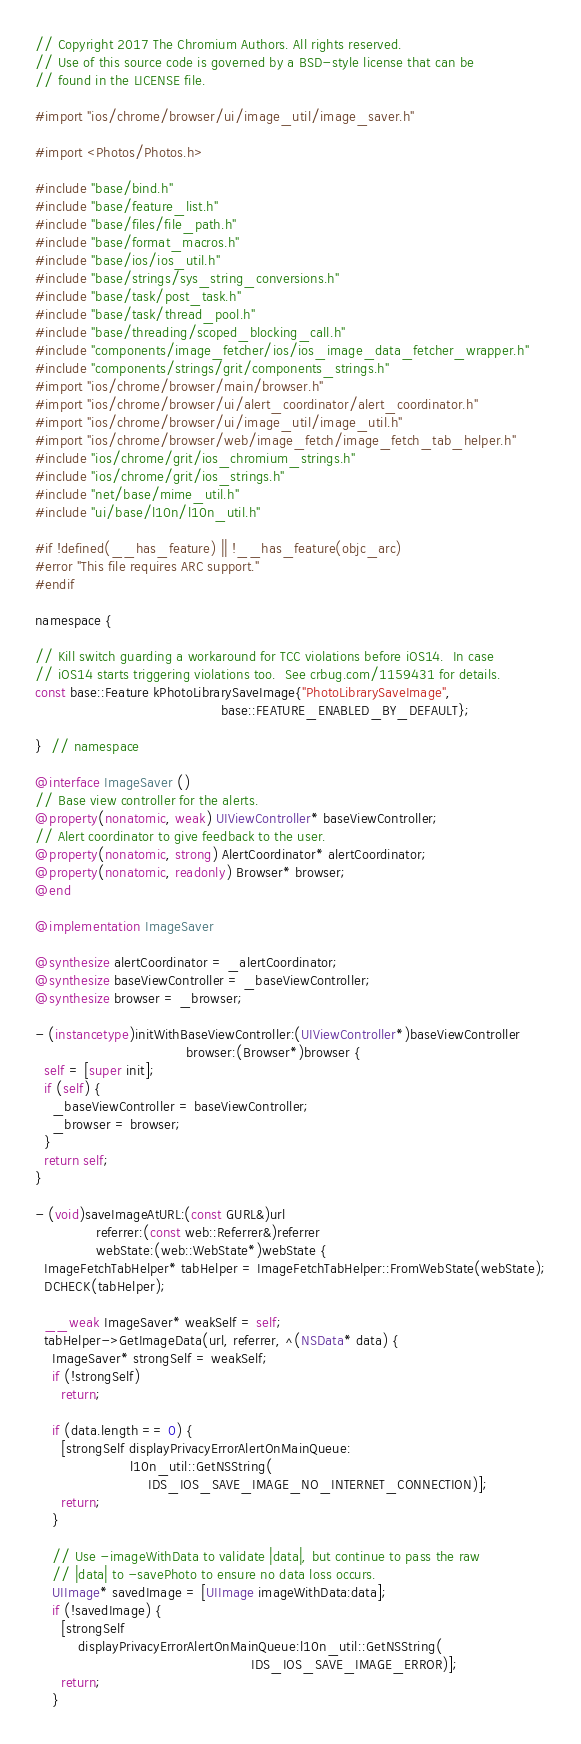Convert code to text. <code><loc_0><loc_0><loc_500><loc_500><_ObjectiveC_>// Copyright 2017 The Chromium Authors. All rights reserved.
// Use of this source code is governed by a BSD-style license that can be
// found in the LICENSE file.

#import "ios/chrome/browser/ui/image_util/image_saver.h"

#import <Photos/Photos.h>

#include "base/bind.h"
#include "base/feature_list.h"
#include "base/files/file_path.h"
#include "base/format_macros.h"
#include "base/ios/ios_util.h"
#include "base/strings/sys_string_conversions.h"
#include "base/task/post_task.h"
#include "base/task/thread_pool.h"
#include "base/threading/scoped_blocking_call.h"
#include "components/image_fetcher/ios/ios_image_data_fetcher_wrapper.h"
#include "components/strings/grit/components_strings.h"
#import "ios/chrome/browser/main/browser.h"
#import "ios/chrome/browser/ui/alert_coordinator/alert_coordinator.h"
#import "ios/chrome/browser/ui/image_util/image_util.h"
#import "ios/chrome/browser/web/image_fetch/image_fetch_tab_helper.h"
#include "ios/chrome/grit/ios_chromium_strings.h"
#include "ios/chrome/grit/ios_strings.h"
#include "net/base/mime_util.h"
#include "ui/base/l10n/l10n_util.h"

#if !defined(__has_feature) || !__has_feature(objc_arc)
#error "This file requires ARC support."
#endif

namespace {

// Kill switch guarding a workaround for TCC violations before iOS14.  In case
// iOS14 starts triggering violations too.  See crbug.com/1159431 for details.
const base::Feature kPhotoLibrarySaveImage{"PhotoLibrarySaveImage",
                                           base::FEATURE_ENABLED_BY_DEFAULT};

}  // namespace

@interface ImageSaver ()
// Base view controller for the alerts.
@property(nonatomic, weak) UIViewController* baseViewController;
// Alert coordinator to give feedback to the user.
@property(nonatomic, strong) AlertCoordinator* alertCoordinator;
@property(nonatomic, readonly) Browser* browser;
@end

@implementation ImageSaver

@synthesize alertCoordinator = _alertCoordinator;
@synthesize baseViewController = _baseViewController;
@synthesize browser = _browser;

- (instancetype)initWithBaseViewController:(UIViewController*)baseViewController
                                   browser:(Browser*)browser {
  self = [super init];
  if (self) {
    _baseViewController = baseViewController;
    _browser = browser;
  }
  return self;
}

- (void)saveImageAtURL:(const GURL&)url
              referrer:(const web::Referrer&)referrer
              webState:(web::WebState*)webState {
  ImageFetchTabHelper* tabHelper = ImageFetchTabHelper::FromWebState(webState);
  DCHECK(tabHelper);

  __weak ImageSaver* weakSelf = self;
  tabHelper->GetImageData(url, referrer, ^(NSData* data) {
    ImageSaver* strongSelf = weakSelf;
    if (!strongSelf)
      return;

    if (data.length == 0) {
      [strongSelf displayPrivacyErrorAlertOnMainQueue:
                      l10n_util::GetNSString(
                          IDS_IOS_SAVE_IMAGE_NO_INTERNET_CONNECTION)];
      return;
    }

    // Use -imageWithData to validate |data|, but continue to pass the raw
    // |data| to -savePhoto to ensure no data loss occurs.
    UIImage* savedImage = [UIImage imageWithData:data];
    if (!savedImage) {
      [strongSelf
          displayPrivacyErrorAlertOnMainQueue:l10n_util::GetNSString(
                                                  IDS_IOS_SAVE_IMAGE_ERROR)];
      return;
    }
</code> 